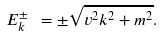<formula> <loc_0><loc_0><loc_500><loc_500>E ^ { \pm } _ { k } \ = \pm \sqrt { v ^ { 2 } { k } ^ { 2 } + m ^ { 2 } } .</formula> 